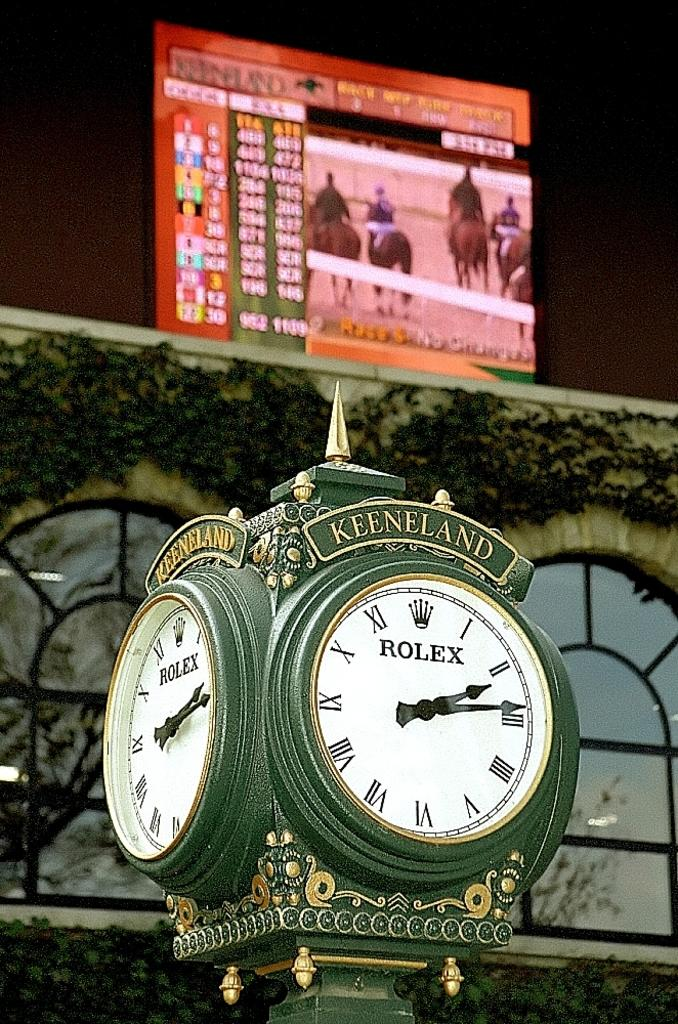Provide a one-sentence caption for the provided image. An old looking clock is displayed with the words rolex and keeneland. 